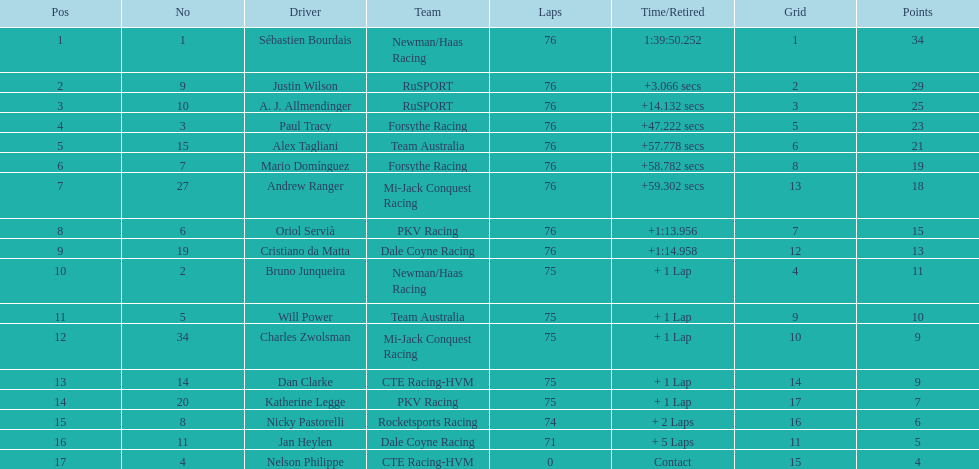Which driver accumulated the fewest points? Nelson Philippe. 